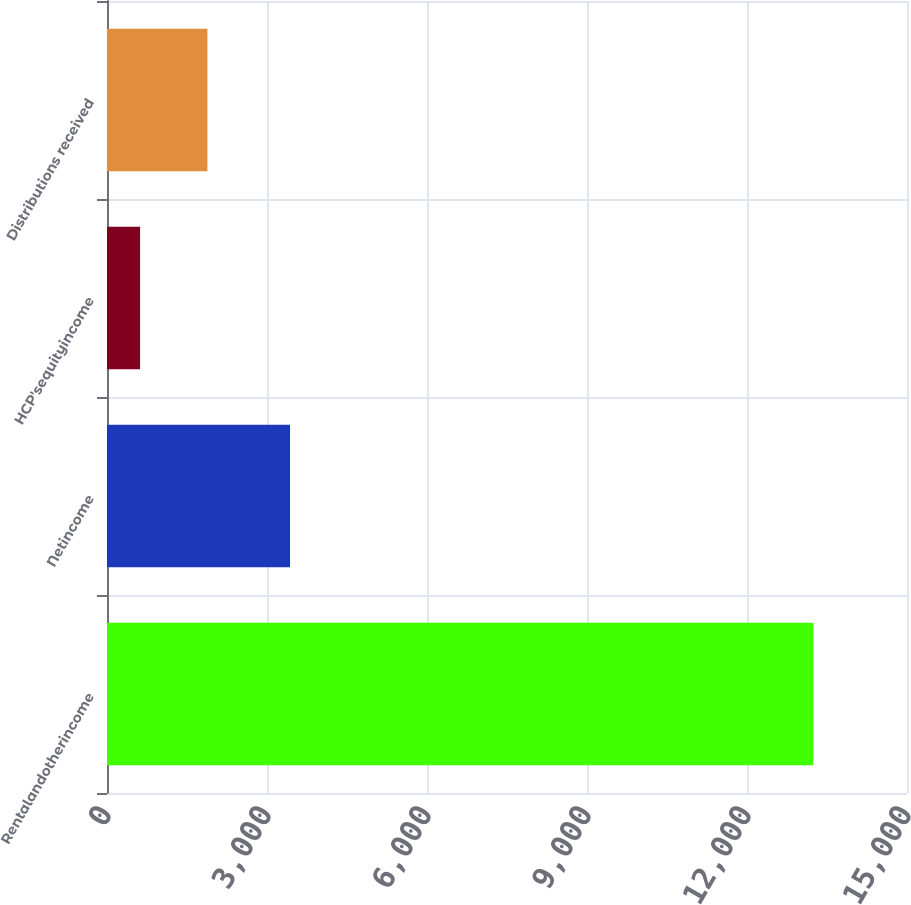<chart> <loc_0><loc_0><loc_500><loc_500><bar_chart><fcel>Rentalandotherincome<fcel>Netincome<fcel>HCP'sequityincome<fcel>Distributions received<nl><fcel>13244<fcel>3432<fcel>620<fcel>1882.4<nl></chart> 